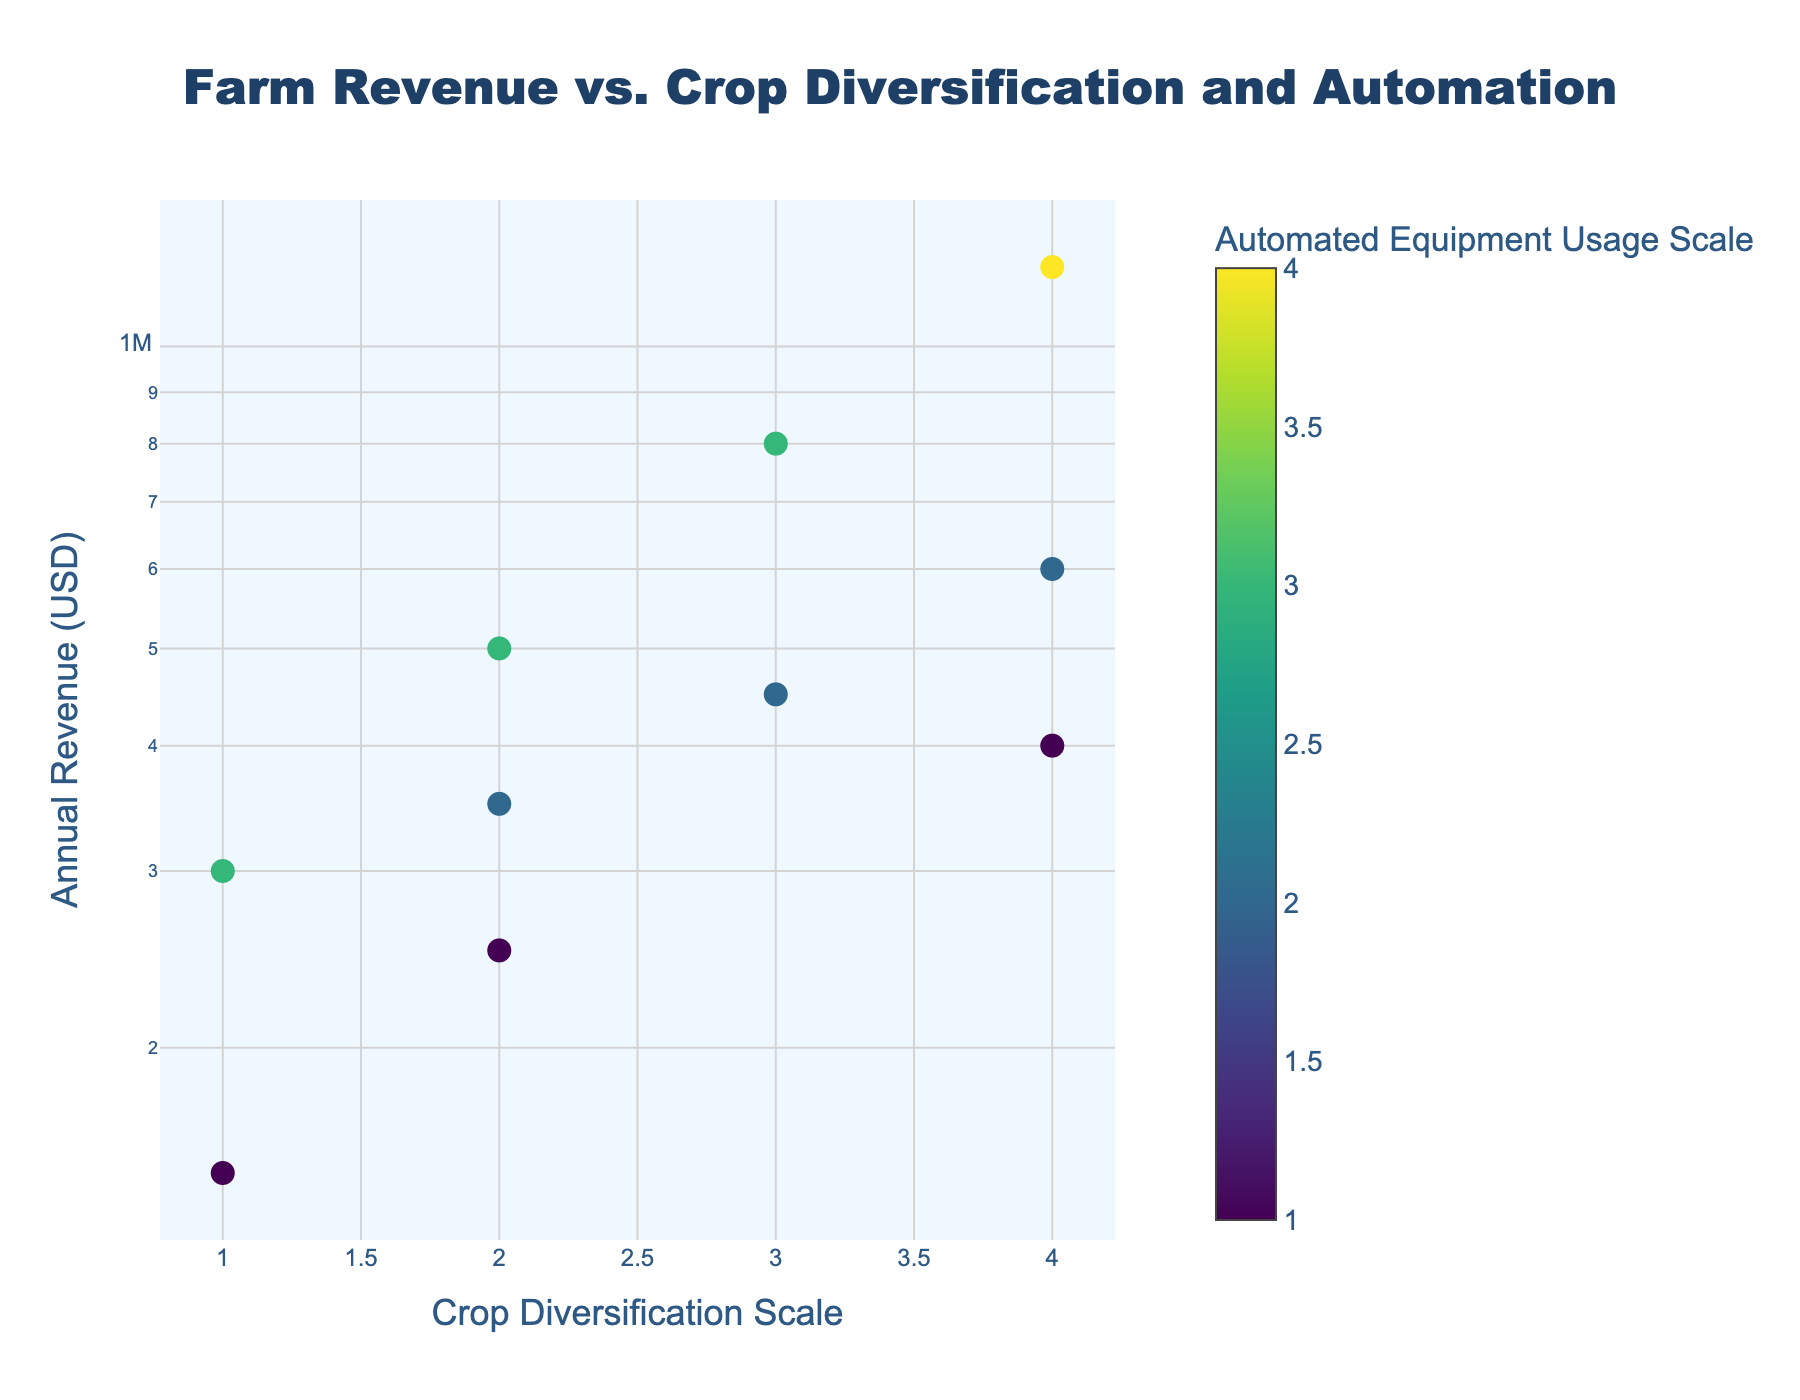What is the title of the plot? The title is usually displayed prominently at the top of the plot. By reading the title, we can understand the main focus of the plot.
Answer: Farm Revenue vs. Crop Diversification and Automation Which farm has the highest annual revenue? By looking at the y-axis, which represents annual revenue, and finding the highest point in the plot, we can identify the farm name from the hover information.
Answer: Blue Sky Farms How many data points are represented in the plot? By counting the number of markers (dots) in the plot, each representing a farm, we can determine the total number of data points.
Answer: 10 What is the color scale representing in the plot? The color of the markers, as indicated by the color bar legend next to the plot, represents the automated equipment usage scale.
Answer: Automated Equipment Usage Scale Which farm has the lowest crop diversification scale but a high annual revenue? Identify the markers with the lowest x-axis value (crop diversification scale) and check the corresponding y-axis value (annual revenue) to find the highest.
Answer: Meadowland Farm How does crop diversification relate to annual revenue for farms using the highest level of automation? By identifying markers in the highest color category (highest automation) and examining their positions along the x-axis (crop diversification) and y-axis (annual revenue), we can analyze the trend.
Answer: Generally, higher crop diversification is associated with higher annual revenue Which farms have a crop diversification scale of 4, and what are their annual revenues? Locate the markers along the x-axis at the value 4 (crop diversification scale) and then check their y-axis values (annual revenue) to find the corresponding revenues.
Answer: Spring Creek Farm ($600,000), Blue Sky Farms ($1,200,000) How does automation impact the annual revenue within the same crop diversification scale? By comparing markers with the same x-axis value (crop diversification scale) but different colors (automation levels), we can analyze the variation in y-axis values (annual revenues).
Answer: Higher automation tends to result in higher annual revenue within the same crop diversification scale Which farm with a crop diversification scale of 2 has the highest annual revenue? Identify the markers at the x-axis value of 2 and check their y-axis values. The marker with the highest y-axis value represents the farm with the highest revenue.
Answer: Fresh Fields What trend can be observed with respect to the log scale on the y-axis? The y-axis uses a logarithmic scale to represent the annual revenue, which means each unit increase on the y-axis represents a tenfold increase in revenue. This can help interpret the relative differences in revenue more easily across a wide range.
Answer: The differences in annual revenue are large, ranging from $150,000 to $1,200,000, illustrating exponential growth in revenue with certain factors such as automation and diversification 